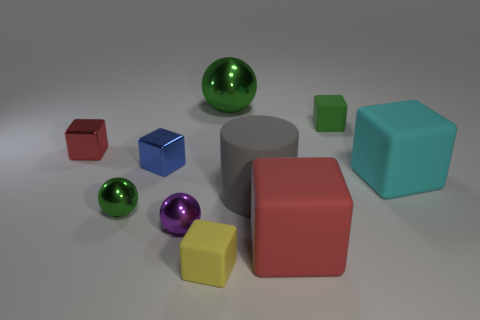Subtract all cyan cubes. How many cubes are left? 5 Subtract all green blocks. How many blocks are left? 5 Subtract all green cubes. Subtract all brown cylinders. How many cubes are left? 5 Subtract all blocks. How many objects are left? 4 Add 4 large cubes. How many large cubes are left? 6 Add 2 big green things. How many big green things exist? 3 Subtract 1 gray cylinders. How many objects are left? 9 Subtract all big gray matte cylinders. Subtract all purple things. How many objects are left? 8 